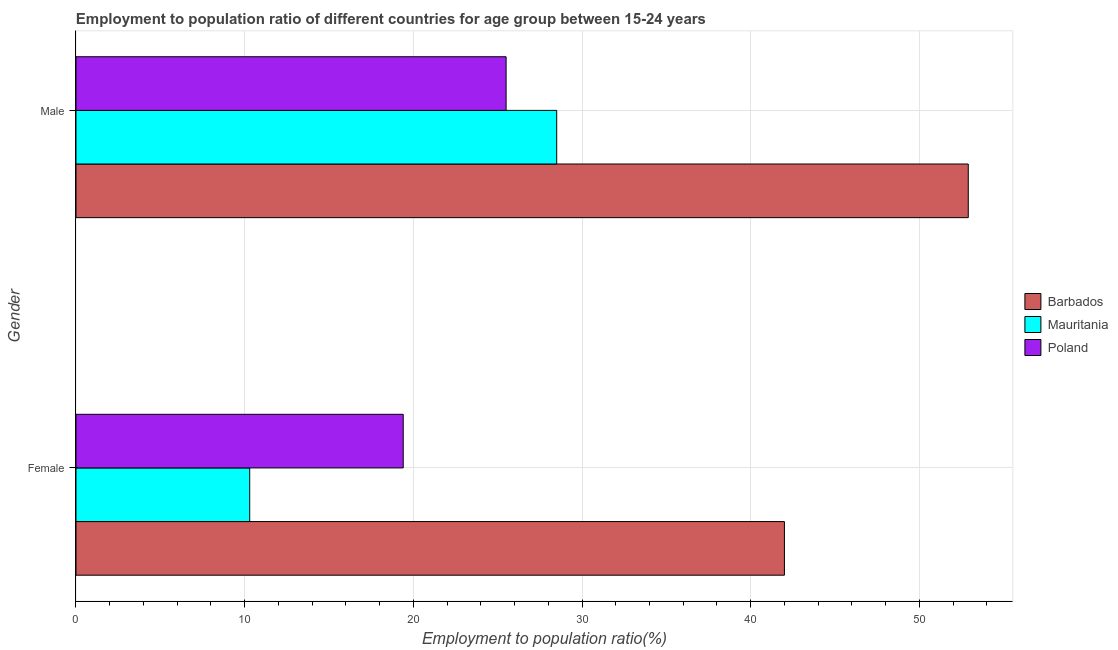How many different coloured bars are there?
Provide a short and direct response. 3. How many groups of bars are there?
Your response must be concise. 2. Are the number of bars per tick equal to the number of legend labels?
Your response must be concise. Yes. How many bars are there on the 2nd tick from the bottom?
Give a very brief answer. 3. What is the label of the 2nd group of bars from the top?
Give a very brief answer. Female. What is the employment to population ratio(female) in Poland?
Make the answer very short. 19.4. Across all countries, what is the minimum employment to population ratio(male)?
Make the answer very short. 25.5. In which country was the employment to population ratio(male) maximum?
Provide a short and direct response. Barbados. In which country was the employment to population ratio(female) minimum?
Your answer should be compact. Mauritania. What is the total employment to population ratio(male) in the graph?
Keep it short and to the point. 106.9. What is the difference between the employment to population ratio(female) in Barbados and that in Poland?
Your answer should be very brief. 22.6. What is the average employment to population ratio(male) per country?
Make the answer very short. 35.63. What is the difference between the employment to population ratio(female) and employment to population ratio(male) in Mauritania?
Your response must be concise. -18.2. In how many countries, is the employment to population ratio(male) greater than 10 %?
Keep it short and to the point. 3. What is the ratio of the employment to population ratio(male) in Barbados to that in Mauritania?
Provide a succinct answer. 1.86. Is the employment to population ratio(female) in Mauritania less than that in Barbados?
Ensure brevity in your answer.  Yes. What does the 2nd bar from the top in Female represents?
Your answer should be compact. Mauritania. What does the 2nd bar from the bottom in Female represents?
Offer a very short reply. Mauritania. Are all the bars in the graph horizontal?
Provide a succinct answer. Yes. How many countries are there in the graph?
Make the answer very short. 3. What is the difference between two consecutive major ticks on the X-axis?
Make the answer very short. 10. Does the graph contain any zero values?
Your answer should be compact. No. Where does the legend appear in the graph?
Make the answer very short. Center right. What is the title of the graph?
Keep it short and to the point. Employment to population ratio of different countries for age group between 15-24 years. Does "Russian Federation" appear as one of the legend labels in the graph?
Your response must be concise. No. What is the label or title of the X-axis?
Provide a succinct answer. Employment to population ratio(%). What is the Employment to population ratio(%) in Barbados in Female?
Your answer should be very brief. 42. What is the Employment to population ratio(%) of Mauritania in Female?
Offer a very short reply. 10.3. What is the Employment to population ratio(%) of Poland in Female?
Your answer should be compact. 19.4. What is the Employment to population ratio(%) of Barbados in Male?
Provide a short and direct response. 52.9. What is the Employment to population ratio(%) of Poland in Male?
Give a very brief answer. 25.5. Across all Gender, what is the maximum Employment to population ratio(%) in Barbados?
Provide a succinct answer. 52.9. Across all Gender, what is the maximum Employment to population ratio(%) of Mauritania?
Your answer should be very brief. 28.5. Across all Gender, what is the minimum Employment to population ratio(%) in Mauritania?
Your answer should be compact. 10.3. Across all Gender, what is the minimum Employment to population ratio(%) in Poland?
Your answer should be very brief. 19.4. What is the total Employment to population ratio(%) in Barbados in the graph?
Give a very brief answer. 94.9. What is the total Employment to population ratio(%) of Mauritania in the graph?
Provide a succinct answer. 38.8. What is the total Employment to population ratio(%) of Poland in the graph?
Make the answer very short. 44.9. What is the difference between the Employment to population ratio(%) of Barbados in Female and that in Male?
Your answer should be compact. -10.9. What is the difference between the Employment to population ratio(%) in Mauritania in Female and that in Male?
Your answer should be compact. -18.2. What is the difference between the Employment to population ratio(%) of Poland in Female and that in Male?
Your response must be concise. -6.1. What is the difference between the Employment to population ratio(%) of Barbados in Female and the Employment to population ratio(%) of Mauritania in Male?
Your answer should be compact. 13.5. What is the difference between the Employment to population ratio(%) of Barbados in Female and the Employment to population ratio(%) of Poland in Male?
Offer a terse response. 16.5. What is the difference between the Employment to population ratio(%) of Mauritania in Female and the Employment to population ratio(%) of Poland in Male?
Provide a succinct answer. -15.2. What is the average Employment to population ratio(%) in Barbados per Gender?
Provide a short and direct response. 47.45. What is the average Employment to population ratio(%) in Poland per Gender?
Your answer should be very brief. 22.45. What is the difference between the Employment to population ratio(%) of Barbados and Employment to population ratio(%) of Mauritania in Female?
Keep it short and to the point. 31.7. What is the difference between the Employment to population ratio(%) of Barbados and Employment to population ratio(%) of Poland in Female?
Give a very brief answer. 22.6. What is the difference between the Employment to population ratio(%) in Mauritania and Employment to population ratio(%) in Poland in Female?
Ensure brevity in your answer.  -9.1. What is the difference between the Employment to population ratio(%) in Barbados and Employment to population ratio(%) in Mauritania in Male?
Give a very brief answer. 24.4. What is the difference between the Employment to population ratio(%) of Barbados and Employment to population ratio(%) of Poland in Male?
Your answer should be very brief. 27.4. What is the difference between the Employment to population ratio(%) of Mauritania and Employment to population ratio(%) of Poland in Male?
Offer a terse response. 3. What is the ratio of the Employment to population ratio(%) of Barbados in Female to that in Male?
Give a very brief answer. 0.79. What is the ratio of the Employment to population ratio(%) of Mauritania in Female to that in Male?
Keep it short and to the point. 0.36. What is the ratio of the Employment to population ratio(%) of Poland in Female to that in Male?
Your answer should be compact. 0.76. What is the difference between the highest and the second highest Employment to population ratio(%) in Barbados?
Offer a terse response. 10.9. What is the difference between the highest and the second highest Employment to population ratio(%) of Mauritania?
Ensure brevity in your answer.  18.2. What is the difference between the highest and the lowest Employment to population ratio(%) of Barbados?
Give a very brief answer. 10.9. What is the difference between the highest and the lowest Employment to population ratio(%) in Mauritania?
Offer a very short reply. 18.2. 